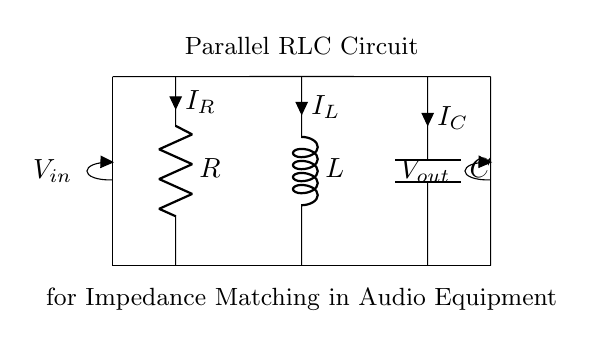What components are in this circuit? The circuit contains a resistor, an inductor, and a capacitor, which are labeled R, L, and C respectively.
Answer: Resistor, Inductor, Capacitor What is the configuration of the circuit? The components are connected in parallel, which is indicated by their arrangement along the same voltage level, connected at both ends to the input and output lines.
Answer: Parallel What is the purpose of this circuit? The circuit is designed for impedance matching, which is indicated by the label stating it is for audio equipment, ensuring efficient power transfer between components.
Answer: Impedance matching What does the label V in the circuit represent? The label V indicates the voltage across the input and output terminals, represented as Vin and Vout. It shows the potential difference supplied to the circuit.
Answer: Voltage Which component carries the current I_L? The current I_L is flowing through the inductor component, labeled L in the diagram.
Answer: Inductor How does the parallel RLC configuration affect the impedance? In a parallel configuration, the total impedance is lowered, as each component provides an alternative path for current, enhancing the circuit's ability to match an external load.
Answer: Lowers impedance What is the influence of the capacitor on this RLC circuit in audio applications? The capacitor allows AC signals to pass while blocking DC, which is crucial for filtering and tuning applications in audio equipment, ensuring only the desired frequencies are processed.
Answer: Filtering 